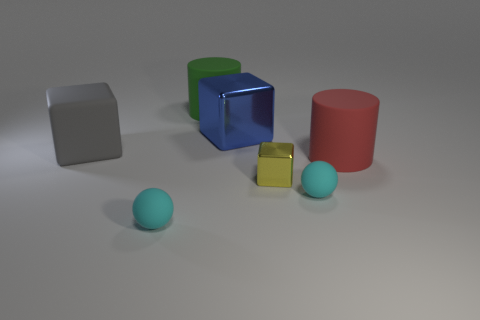Subtract all large blue blocks. How many blocks are left? 2 Add 1 big gray things. How many objects exist? 8 Subtract all cubes. How many objects are left? 4 Subtract all brown blocks. Subtract all purple balls. How many blocks are left? 3 Subtract all green matte cylinders. Subtract all large rubber cylinders. How many objects are left? 4 Add 7 gray rubber objects. How many gray rubber objects are left? 8 Add 4 yellow blocks. How many yellow blocks exist? 5 Subtract 0 yellow balls. How many objects are left? 7 